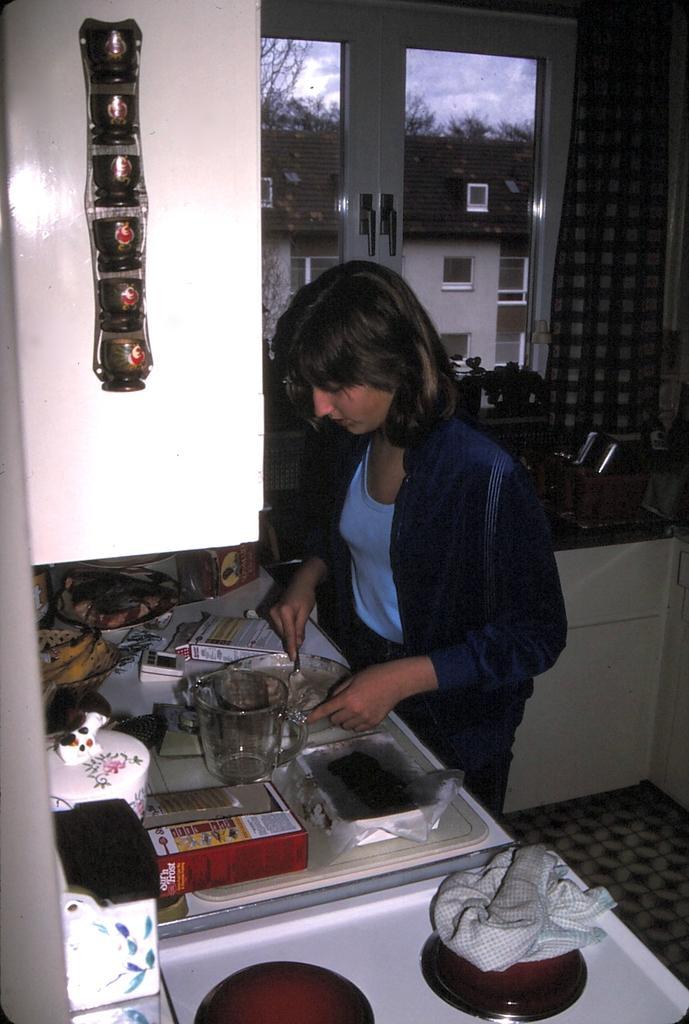Could you give a brief overview of what you see in this image? In this picture we can see a woman standing in front of a counter top, there is a jug, a box, a bowl, a plate and some other things present on the counter top, we can see a cloth here, in the background there is a window, from the window we can see a house and a tree, there are plants here. 